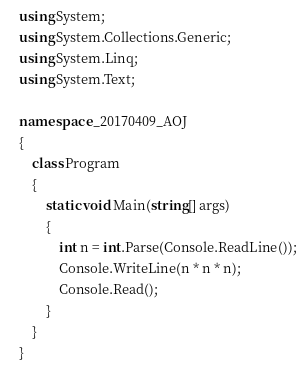Convert code to text. <code><loc_0><loc_0><loc_500><loc_500><_C#_>using System;
using System.Collections.Generic;
using System.Linq;
using System.Text;

namespace _20170409_AOJ
{
    class Program
    {
        static void Main(string[] args)
        {
            int n = int.Parse(Console.ReadLine());
            Console.WriteLine(n * n * n);
            Console.Read();
        }
    }
}</code> 